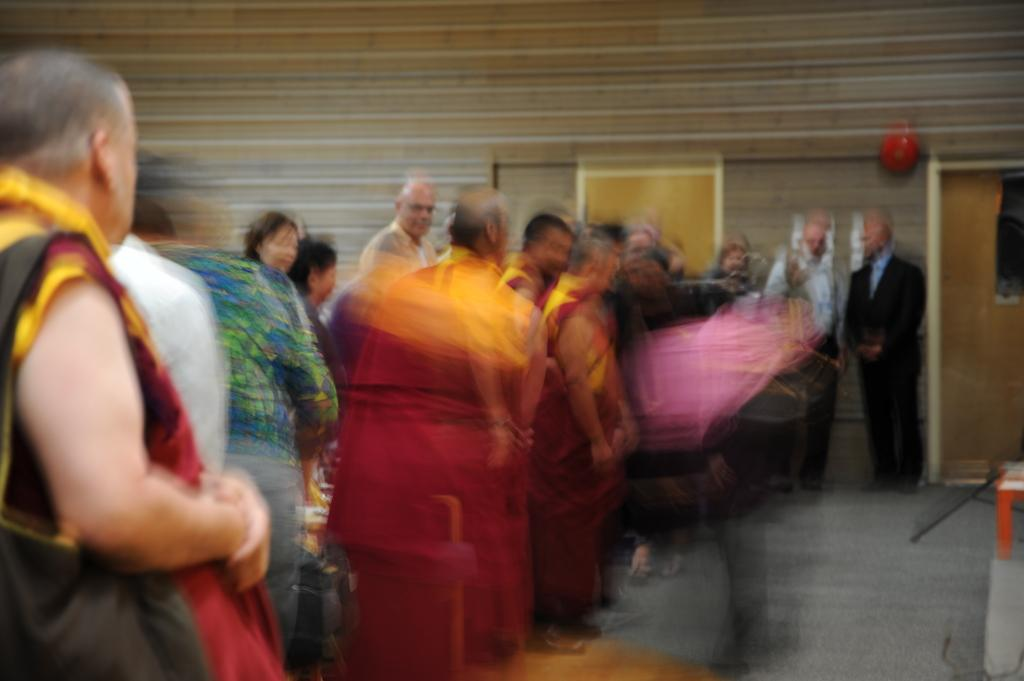What are the people in the image doing? The people in the image are standing. Where are the people standing in the image? The people are standing on the floor. What can be seen in the background of the image? There is a wall and a door in the background of the image. What else is present in the image besides the people and the background? There are objects in the image. What type of stone is being exchanged between the people in the image? There is no stone or exchange of any kind depicted in the image. 